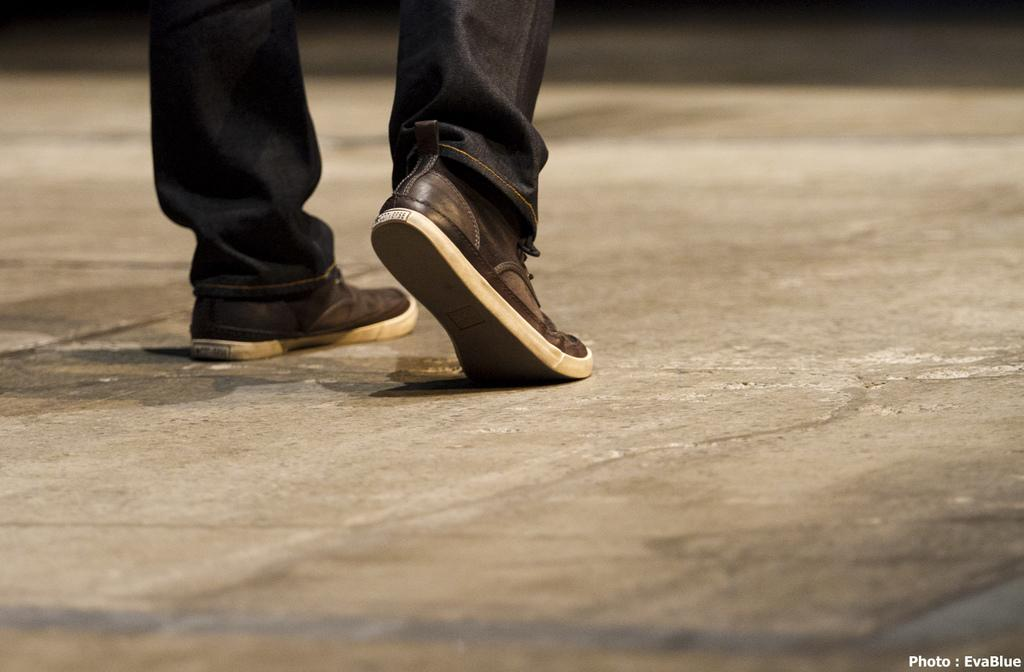What body part is visible in the image? There are person's legs visible in the image. What type of clothing is the person wearing on their legs? The person is wearing footwear. Where are the legs located in the image? The legs are on the floor. Is there any text present in the image? Yes, there is a text in the bottom right corner of the image. What type of wood can be seen in the image? There is no wood present in the image; it features a person's legs on the floor. What kind of jewel is the person wearing on their legs? There is no jewel present on the person's legs in the image. 